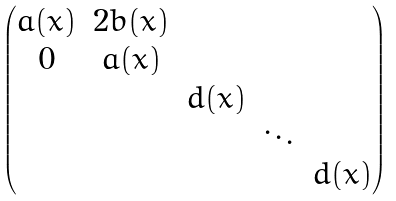Convert formula to latex. <formula><loc_0><loc_0><loc_500><loc_500>\begin{pmatrix} a ( x ) & 2 b ( x ) & & & \\ 0 & a ( x ) & & & \\ & & d ( x ) & & \\ & & & \ddots & \\ & & & & d ( x ) \end{pmatrix}</formula> 